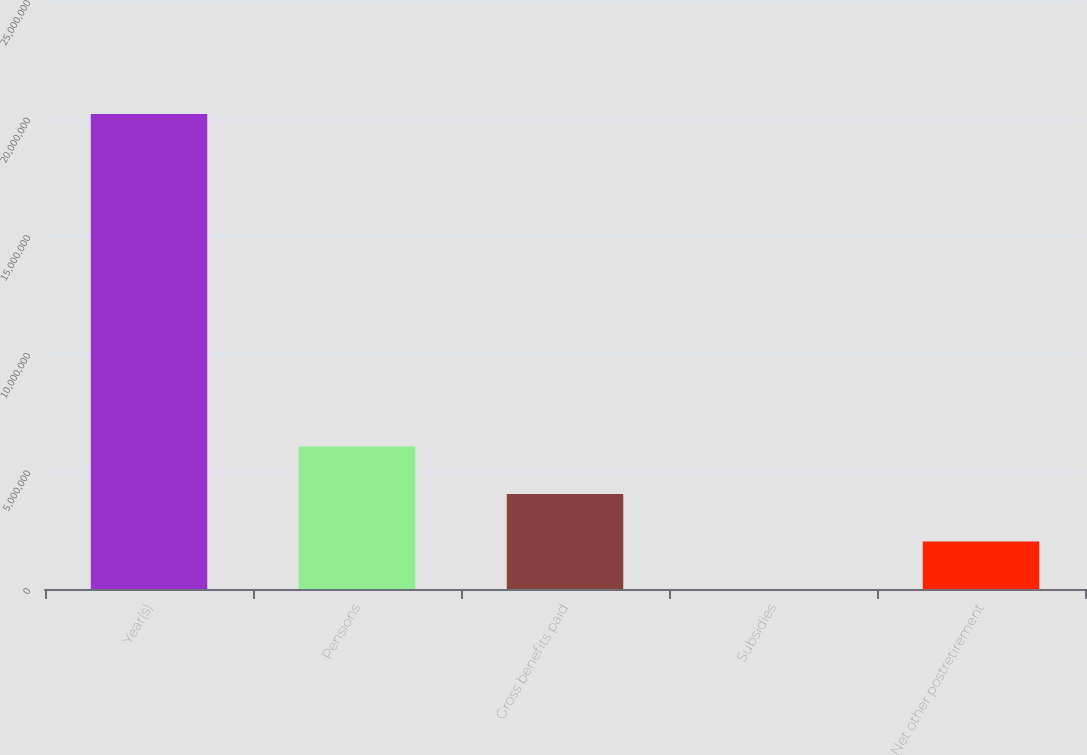Convert chart to OTSL. <chart><loc_0><loc_0><loc_500><loc_500><bar_chart><fcel>Year(s)<fcel>Pensions<fcel>Gross benefits paid<fcel>Subsidies<fcel>Net other postretirement<nl><fcel>2.0192e+07<fcel>6.05776e+06<fcel>4.03858e+06<fcel>215<fcel>2.0194e+06<nl></chart> 